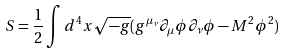<formula> <loc_0><loc_0><loc_500><loc_500>S = \frac { 1 } { 2 } \int d ^ { 4 } x \sqrt { - g } ( g ^ { \mu _ { \nu } } \partial _ { \mu } \phi \partial _ { \nu } \phi - M ^ { 2 } \phi ^ { 2 } )</formula> 